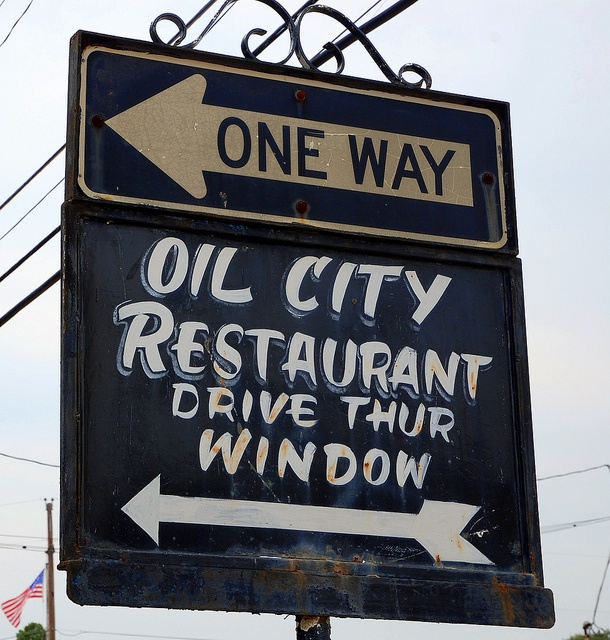Describe the objects in this image and their specific colors. I can see various objects in this image with different colors. 